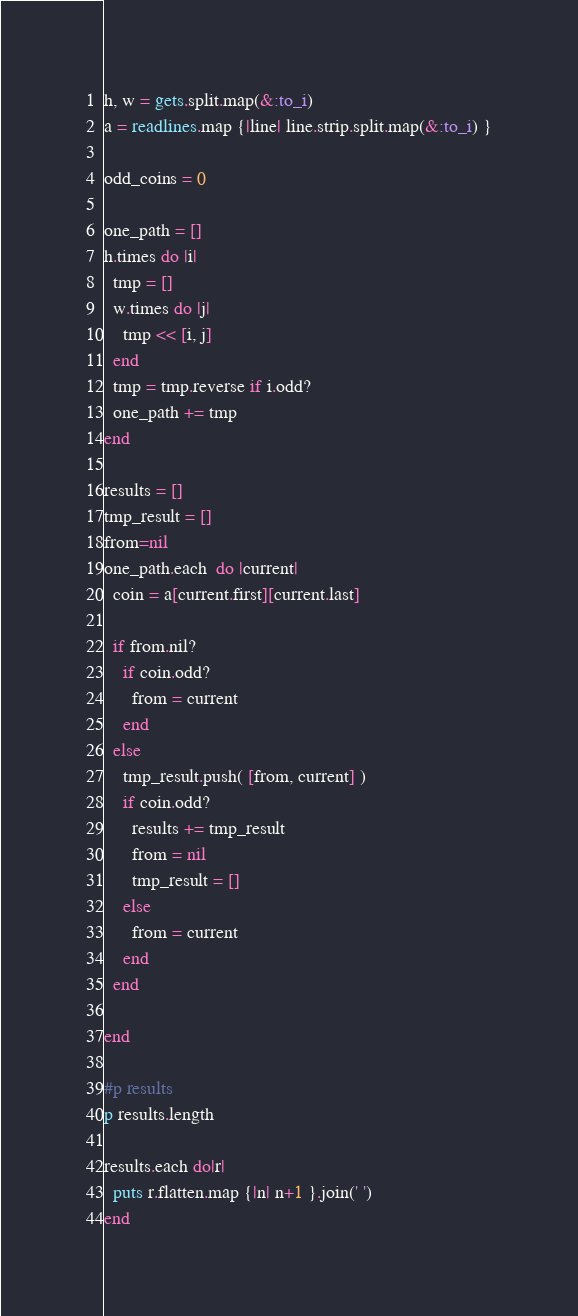Convert code to text. <code><loc_0><loc_0><loc_500><loc_500><_Ruby_>h, w = gets.split.map(&:to_i)
a = readlines.map {|line| line.strip.split.map(&:to_i) }

odd_coins = 0

one_path = []
h.times do |i|
  tmp = []
  w.times do |j|
    tmp << [i, j]
  end
  tmp = tmp.reverse if i.odd?
  one_path += tmp
end

results = []
tmp_result = []
from=nil
one_path.each  do |current|
  coin = a[current.first][current.last]

  if from.nil?
    if coin.odd?
      from = current 
    end
  else
    tmp_result.push( [from, current] )
    if coin.odd?
      results += tmp_result
      from = nil
      tmp_result = []
    else
      from = current 
    end
  end

end

#p results
p results.length

results.each do|r|
  puts r.flatten.map {|n| n+1 }.join(' ')
end
</code> 